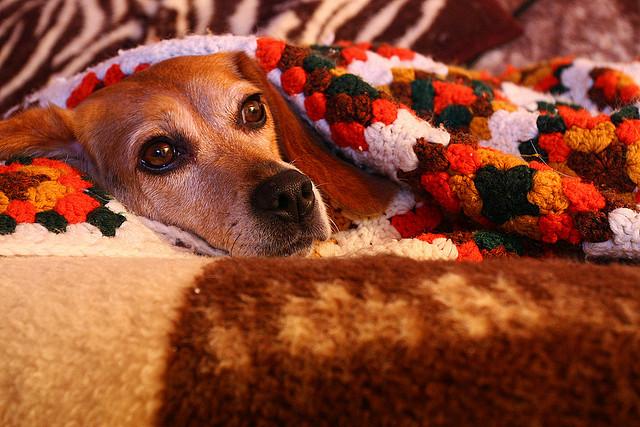What kind of blanket is over the dog?
Be succinct. Crocheted. What color is the dog?
Short answer required. Brown. Is the dog barking?
Quick response, please. No. 